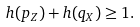<formula> <loc_0><loc_0><loc_500><loc_500>h ( p _ { Z } ) + h ( q _ { X } ) \geq 1 .</formula> 